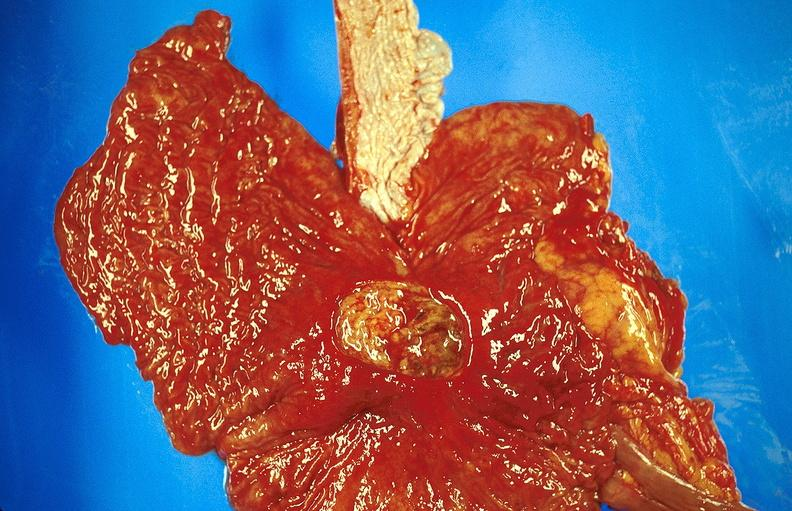does this image show gastric ulcer?
Answer the question using a single word or phrase. Yes 